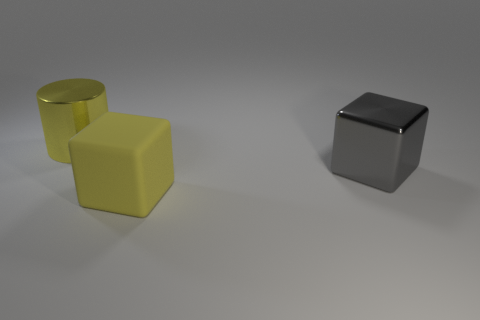Add 1 gray metal objects. How many objects exist? 4 Subtract all cylinders. How many objects are left? 2 Subtract 0 cyan cylinders. How many objects are left? 3 Subtract all big yellow things. Subtract all large yellow matte blocks. How many objects are left? 0 Add 1 large yellow cylinders. How many large yellow cylinders are left? 2 Add 1 small brown shiny cylinders. How many small brown shiny cylinders exist? 1 